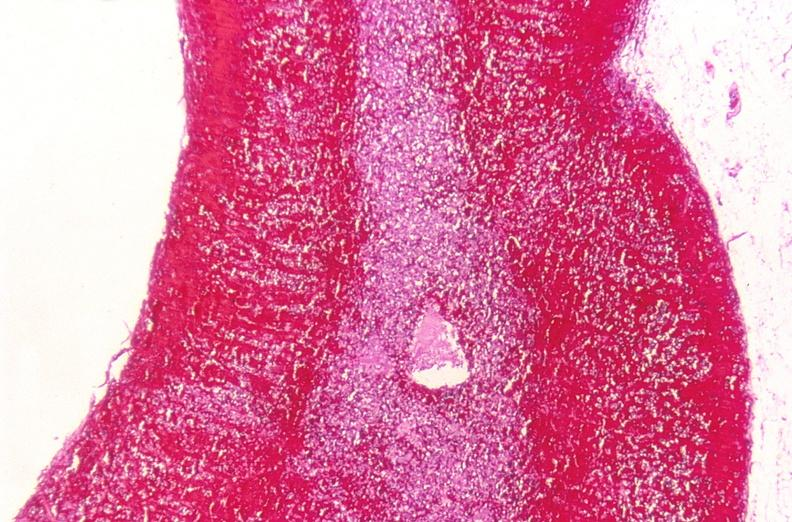does hemorrhage associated with placental abruption show adrenal gland, severe hemorrhage waterhouse-friderichsen syndrome?
Answer the question using a single word or phrase. No 